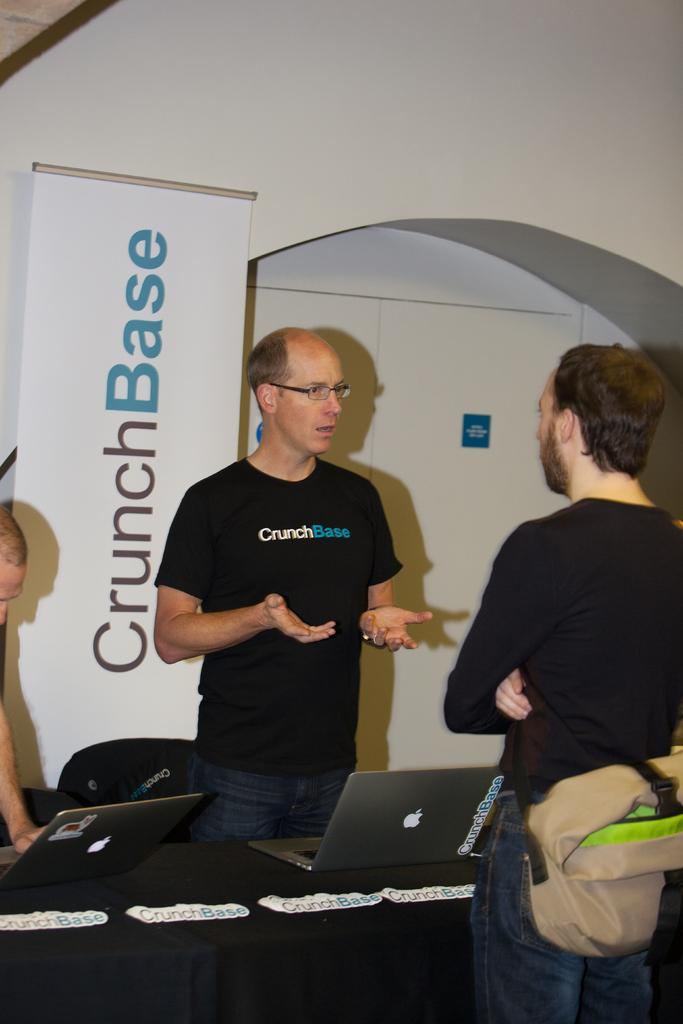What are the people in the image doing? The people in the image are standing in the center. What is in front of the people? There is a table before the people. What is on the table? Laptops are placed on the table. What can be seen in the background of the image? There is a banner and a wall in the background of the image. What type of loaf is being sliced on the table in the image? There is no loaf present in the image; the table has laptops on it. What date is marked on the calendar in the image? There is no calendar present in the image. 